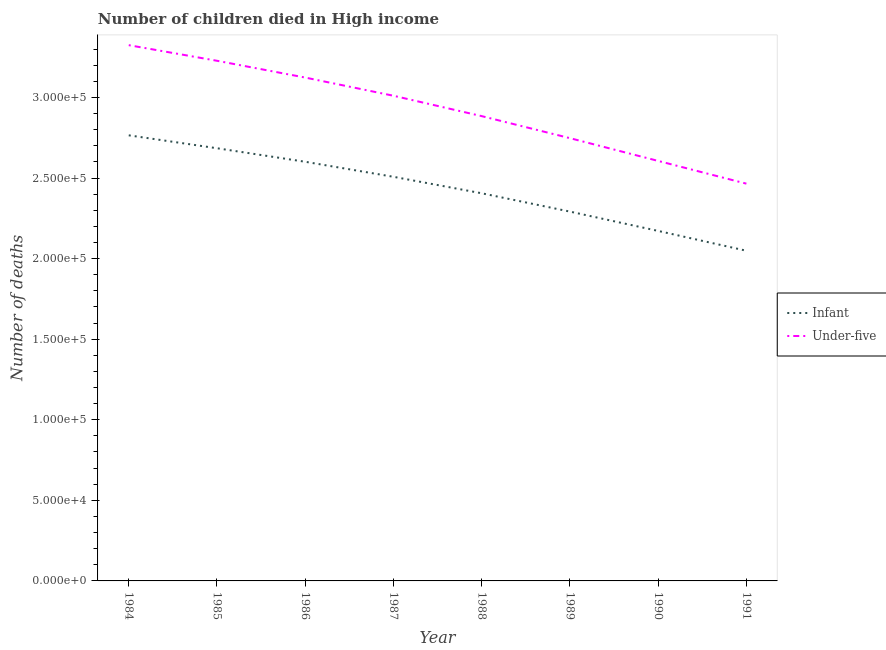How many different coloured lines are there?
Your answer should be compact. 2. Is the number of lines equal to the number of legend labels?
Provide a succinct answer. Yes. What is the number of infant deaths in 1989?
Provide a succinct answer. 2.29e+05. Across all years, what is the maximum number of under-five deaths?
Your response must be concise. 3.32e+05. Across all years, what is the minimum number of under-five deaths?
Provide a short and direct response. 2.46e+05. In which year was the number of infant deaths maximum?
Provide a succinct answer. 1984. In which year was the number of under-five deaths minimum?
Keep it short and to the point. 1991. What is the total number of under-five deaths in the graph?
Make the answer very short. 2.34e+06. What is the difference between the number of under-five deaths in 1987 and that in 1991?
Keep it short and to the point. 5.46e+04. What is the difference between the number of under-five deaths in 1986 and the number of infant deaths in 1984?
Provide a short and direct response. 3.58e+04. What is the average number of under-five deaths per year?
Offer a terse response. 2.92e+05. In the year 1988, what is the difference between the number of under-five deaths and number of infant deaths?
Your answer should be compact. 4.79e+04. What is the ratio of the number of under-five deaths in 1988 to that in 1991?
Your response must be concise. 1.17. Is the difference between the number of infant deaths in 1990 and 1991 greater than the difference between the number of under-five deaths in 1990 and 1991?
Provide a succinct answer. No. What is the difference between the highest and the second highest number of under-five deaths?
Provide a short and direct response. 9692. What is the difference between the highest and the lowest number of infant deaths?
Provide a succinct answer. 7.16e+04. In how many years, is the number of infant deaths greater than the average number of infant deaths taken over all years?
Keep it short and to the point. 4. How many lines are there?
Your answer should be compact. 2. Does the graph contain any zero values?
Give a very brief answer. No. How many legend labels are there?
Your answer should be very brief. 2. How are the legend labels stacked?
Your answer should be compact. Vertical. What is the title of the graph?
Your answer should be very brief. Number of children died in High income. What is the label or title of the X-axis?
Offer a very short reply. Year. What is the label or title of the Y-axis?
Keep it short and to the point. Number of deaths. What is the Number of deaths of Infant in 1984?
Keep it short and to the point. 2.76e+05. What is the Number of deaths of Under-five in 1984?
Make the answer very short. 3.32e+05. What is the Number of deaths in Infant in 1985?
Ensure brevity in your answer.  2.68e+05. What is the Number of deaths in Under-five in 1985?
Ensure brevity in your answer.  3.23e+05. What is the Number of deaths in Infant in 1986?
Provide a succinct answer. 2.60e+05. What is the Number of deaths of Under-five in 1986?
Offer a terse response. 3.12e+05. What is the Number of deaths in Infant in 1987?
Provide a succinct answer. 2.51e+05. What is the Number of deaths of Under-five in 1987?
Give a very brief answer. 3.01e+05. What is the Number of deaths of Infant in 1988?
Give a very brief answer. 2.41e+05. What is the Number of deaths of Under-five in 1988?
Provide a short and direct response. 2.88e+05. What is the Number of deaths of Infant in 1989?
Provide a succinct answer. 2.29e+05. What is the Number of deaths in Under-five in 1989?
Make the answer very short. 2.75e+05. What is the Number of deaths in Infant in 1990?
Offer a terse response. 2.17e+05. What is the Number of deaths of Under-five in 1990?
Ensure brevity in your answer.  2.61e+05. What is the Number of deaths of Infant in 1991?
Provide a short and direct response. 2.05e+05. What is the Number of deaths of Under-five in 1991?
Offer a terse response. 2.46e+05. Across all years, what is the maximum Number of deaths of Infant?
Your response must be concise. 2.76e+05. Across all years, what is the maximum Number of deaths in Under-five?
Offer a very short reply. 3.32e+05. Across all years, what is the minimum Number of deaths in Infant?
Your answer should be compact. 2.05e+05. Across all years, what is the minimum Number of deaths of Under-five?
Make the answer very short. 2.46e+05. What is the total Number of deaths of Infant in the graph?
Offer a very short reply. 1.95e+06. What is the total Number of deaths in Under-five in the graph?
Your answer should be very brief. 2.34e+06. What is the difference between the Number of deaths of Infant in 1984 and that in 1985?
Keep it short and to the point. 8018. What is the difference between the Number of deaths of Under-five in 1984 and that in 1985?
Keep it short and to the point. 9692. What is the difference between the Number of deaths in Infant in 1984 and that in 1986?
Ensure brevity in your answer.  1.64e+04. What is the difference between the Number of deaths in Under-five in 1984 and that in 1986?
Offer a very short reply. 2.01e+04. What is the difference between the Number of deaths in Infant in 1984 and that in 1987?
Give a very brief answer. 2.57e+04. What is the difference between the Number of deaths of Under-five in 1984 and that in 1987?
Ensure brevity in your answer.  3.14e+04. What is the difference between the Number of deaths in Infant in 1984 and that in 1988?
Give a very brief answer. 3.60e+04. What is the difference between the Number of deaths of Under-five in 1984 and that in 1988?
Your answer should be compact. 4.40e+04. What is the difference between the Number of deaths in Infant in 1984 and that in 1989?
Offer a very short reply. 4.73e+04. What is the difference between the Number of deaths of Under-five in 1984 and that in 1989?
Keep it short and to the point. 5.77e+04. What is the difference between the Number of deaths in Infant in 1984 and that in 1990?
Provide a succinct answer. 5.93e+04. What is the difference between the Number of deaths in Under-five in 1984 and that in 1990?
Ensure brevity in your answer.  7.18e+04. What is the difference between the Number of deaths of Infant in 1984 and that in 1991?
Give a very brief answer. 7.16e+04. What is the difference between the Number of deaths of Under-five in 1984 and that in 1991?
Your answer should be very brief. 8.59e+04. What is the difference between the Number of deaths of Infant in 1985 and that in 1986?
Your answer should be compact. 8395. What is the difference between the Number of deaths of Under-five in 1985 and that in 1986?
Ensure brevity in your answer.  1.04e+04. What is the difference between the Number of deaths in Infant in 1985 and that in 1987?
Your answer should be compact. 1.77e+04. What is the difference between the Number of deaths in Under-five in 1985 and that in 1987?
Make the answer very short. 2.17e+04. What is the difference between the Number of deaths of Infant in 1985 and that in 1988?
Your answer should be very brief. 2.79e+04. What is the difference between the Number of deaths in Under-five in 1985 and that in 1988?
Give a very brief answer. 3.43e+04. What is the difference between the Number of deaths of Infant in 1985 and that in 1989?
Offer a terse response. 3.93e+04. What is the difference between the Number of deaths of Under-five in 1985 and that in 1989?
Make the answer very short. 4.80e+04. What is the difference between the Number of deaths in Infant in 1985 and that in 1990?
Offer a very short reply. 5.13e+04. What is the difference between the Number of deaths in Under-five in 1985 and that in 1990?
Offer a terse response. 6.21e+04. What is the difference between the Number of deaths of Infant in 1985 and that in 1991?
Your answer should be very brief. 6.36e+04. What is the difference between the Number of deaths in Under-five in 1985 and that in 1991?
Make the answer very short. 7.62e+04. What is the difference between the Number of deaths of Infant in 1986 and that in 1987?
Provide a succinct answer. 9321. What is the difference between the Number of deaths in Under-five in 1986 and that in 1987?
Offer a very short reply. 1.13e+04. What is the difference between the Number of deaths of Infant in 1986 and that in 1988?
Provide a succinct answer. 1.95e+04. What is the difference between the Number of deaths in Under-five in 1986 and that in 1988?
Provide a short and direct response. 2.39e+04. What is the difference between the Number of deaths of Infant in 1986 and that in 1989?
Keep it short and to the point. 3.09e+04. What is the difference between the Number of deaths of Under-five in 1986 and that in 1989?
Give a very brief answer. 3.76e+04. What is the difference between the Number of deaths of Infant in 1986 and that in 1990?
Your response must be concise. 4.29e+04. What is the difference between the Number of deaths of Under-five in 1986 and that in 1990?
Your answer should be very brief. 5.17e+04. What is the difference between the Number of deaths of Infant in 1986 and that in 1991?
Ensure brevity in your answer.  5.52e+04. What is the difference between the Number of deaths in Under-five in 1986 and that in 1991?
Provide a succinct answer. 6.58e+04. What is the difference between the Number of deaths of Infant in 1987 and that in 1988?
Your answer should be compact. 1.02e+04. What is the difference between the Number of deaths of Under-five in 1987 and that in 1988?
Keep it short and to the point. 1.26e+04. What is the difference between the Number of deaths of Infant in 1987 and that in 1989?
Provide a short and direct response. 2.16e+04. What is the difference between the Number of deaths in Under-five in 1987 and that in 1989?
Ensure brevity in your answer.  2.63e+04. What is the difference between the Number of deaths of Infant in 1987 and that in 1990?
Offer a terse response. 3.36e+04. What is the difference between the Number of deaths of Under-five in 1987 and that in 1990?
Ensure brevity in your answer.  4.04e+04. What is the difference between the Number of deaths in Infant in 1987 and that in 1991?
Offer a terse response. 4.59e+04. What is the difference between the Number of deaths of Under-five in 1987 and that in 1991?
Your answer should be compact. 5.46e+04. What is the difference between the Number of deaths of Infant in 1988 and that in 1989?
Offer a terse response. 1.14e+04. What is the difference between the Number of deaths of Under-five in 1988 and that in 1989?
Give a very brief answer. 1.37e+04. What is the difference between the Number of deaths in Infant in 1988 and that in 1990?
Ensure brevity in your answer.  2.34e+04. What is the difference between the Number of deaths in Under-five in 1988 and that in 1990?
Offer a terse response. 2.78e+04. What is the difference between the Number of deaths in Infant in 1988 and that in 1991?
Offer a very short reply. 3.57e+04. What is the difference between the Number of deaths of Under-five in 1988 and that in 1991?
Your answer should be very brief. 4.19e+04. What is the difference between the Number of deaths of Infant in 1989 and that in 1990?
Your response must be concise. 1.20e+04. What is the difference between the Number of deaths in Under-five in 1989 and that in 1990?
Your answer should be compact. 1.41e+04. What is the difference between the Number of deaths of Infant in 1989 and that in 1991?
Give a very brief answer. 2.43e+04. What is the difference between the Number of deaths in Under-five in 1989 and that in 1991?
Provide a succinct answer. 2.82e+04. What is the difference between the Number of deaths in Infant in 1990 and that in 1991?
Provide a short and direct response. 1.23e+04. What is the difference between the Number of deaths of Under-five in 1990 and that in 1991?
Offer a very short reply. 1.41e+04. What is the difference between the Number of deaths of Infant in 1984 and the Number of deaths of Under-five in 1985?
Give a very brief answer. -4.63e+04. What is the difference between the Number of deaths in Infant in 1984 and the Number of deaths in Under-five in 1986?
Your answer should be very brief. -3.58e+04. What is the difference between the Number of deaths of Infant in 1984 and the Number of deaths of Under-five in 1987?
Provide a short and direct response. -2.46e+04. What is the difference between the Number of deaths of Infant in 1984 and the Number of deaths of Under-five in 1988?
Your response must be concise. -1.19e+04. What is the difference between the Number of deaths of Infant in 1984 and the Number of deaths of Under-five in 1989?
Your response must be concise. 1762. What is the difference between the Number of deaths of Infant in 1984 and the Number of deaths of Under-five in 1990?
Your response must be concise. 1.59e+04. What is the difference between the Number of deaths in Infant in 1984 and the Number of deaths in Under-five in 1991?
Your answer should be compact. 3.00e+04. What is the difference between the Number of deaths in Infant in 1985 and the Number of deaths in Under-five in 1986?
Provide a succinct answer. -4.39e+04. What is the difference between the Number of deaths in Infant in 1985 and the Number of deaths in Under-five in 1987?
Your answer should be compact. -3.26e+04. What is the difference between the Number of deaths in Infant in 1985 and the Number of deaths in Under-five in 1988?
Offer a terse response. -1.99e+04. What is the difference between the Number of deaths of Infant in 1985 and the Number of deaths of Under-five in 1989?
Keep it short and to the point. -6256. What is the difference between the Number of deaths of Infant in 1985 and the Number of deaths of Under-five in 1990?
Your answer should be very brief. 7872. What is the difference between the Number of deaths in Infant in 1985 and the Number of deaths in Under-five in 1991?
Offer a terse response. 2.20e+04. What is the difference between the Number of deaths in Infant in 1986 and the Number of deaths in Under-five in 1987?
Offer a very short reply. -4.10e+04. What is the difference between the Number of deaths of Infant in 1986 and the Number of deaths of Under-five in 1988?
Your response must be concise. -2.83e+04. What is the difference between the Number of deaths in Infant in 1986 and the Number of deaths in Under-five in 1989?
Provide a succinct answer. -1.47e+04. What is the difference between the Number of deaths in Infant in 1986 and the Number of deaths in Under-five in 1990?
Ensure brevity in your answer.  -523. What is the difference between the Number of deaths of Infant in 1986 and the Number of deaths of Under-five in 1991?
Give a very brief answer. 1.36e+04. What is the difference between the Number of deaths of Infant in 1987 and the Number of deaths of Under-five in 1988?
Ensure brevity in your answer.  -3.76e+04. What is the difference between the Number of deaths of Infant in 1987 and the Number of deaths of Under-five in 1989?
Offer a very short reply. -2.40e+04. What is the difference between the Number of deaths of Infant in 1987 and the Number of deaths of Under-five in 1990?
Your response must be concise. -9844. What is the difference between the Number of deaths in Infant in 1987 and the Number of deaths in Under-five in 1991?
Offer a terse response. 4261. What is the difference between the Number of deaths of Infant in 1988 and the Number of deaths of Under-five in 1989?
Make the answer very short. -3.42e+04. What is the difference between the Number of deaths of Infant in 1988 and the Number of deaths of Under-five in 1990?
Ensure brevity in your answer.  -2.01e+04. What is the difference between the Number of deaths of Infant in 1988 and the Number of deaths of Under-five in 1991?
Offer a terse response. -5960. What is the difference between the Number of deaths of Infant in 1989 and the Number of deaths of Under-five in 1990?
Your answer should be very brief. -3.14e+04. What is the difference between the Number of deaths of Infant in 1989 and the Number of deaths of Under-five in 1991?
Provide a succinct answer. -1.73e+04. What is the difference between the Number of deaths in Infant in 1990 and the Number of deaths in Under-five in 1991?
Keep it short and to the point. -2.93e+04. What is the average Number of deaths in Infant per year?
Offer a very short reply. 2.43e+05. What is the average Number of deaths in Under-five per year?
Provide a short and direct response. 2.92e+05. In the year 1984, what is the difference between the Number of deaths of Infant and Number of deaths of Under-five?
Keep it short and to the point. -5.59e+04. In the year 1985, what is the difference between the Number of deaths of Infant and Number of deaths of Under-five?
Make the answer very short. -5.43e+04. In the year 1986, what is the difference between the Number of deaths in Infant and Number of deaths in Under-five?
Your response must be concise. -5.23e+04. In the year 1987, what is the difference between the Number of deaths in Infant and Number of deaths in Under-five?
Offer a terse response. -5.03e+04. In the year 1988, what is the difference between the Number of deaths in Infant and Number of deaths in Under-five?
Ensure brevity in your answer.  -4.79e+04. In the year 1989, what is the difference between the Number of deaths in Infant and Number of deaths in Under-five?
Give a very brief answer. -4.56e+04. In the year 1990, what is the difference between the Number of deaths in Infant and Number of deaths in Under-five?
Give a very brief answer. -4.34e+04. In the year 1991, what is the difference between the Number of deaths in Infant and Number of deaths in Under-five?
Your answer should be very brief. -4.16e+04. What is the ratio of the Number of deaths of Infant in 1984 to that in 1985?
Provide a succinct answer. 1.03. What is the ratio of the Number of deaths in Infant in 1984 to that in 1986?
Offer a very short reply. 1.06. What is the ratio of the Number of deaths in Under-five in 1984 to that in 1986?
Ensure brevity in your answer.  1.06. What is the ratio of the Number of deaths of Infant in 1984 to that in 1987?
Provide a short and direct response. 1.1. What is the ratio of the Number of deaths of Under-five in 1984 to that in 1987?
Ensure brevity in your answer.  1.1. What is the ratio of the Number of deaths of Infant in 1984 to that in 1988?
Make the answer very short. 1.15. What is the ratio of the Number of deaths of Under-five in 1984 to that in 1988?
Make the answer very short. 1.15. What is the ratio of the Number of deaths of Infant in 1984 to that in 1989?
Your response must be concise. 1.21. What is the ratio of the Number of deaths in Under-five in 1984 to that in 1989?
Offer a very short reply. 1.21. What is the ratio of the Number of deaths in Infant in 1984 to that in 1990?
Your answer should be compact. 1.27. What is the ratio of the Number of deaths of Under-five in 1984 to that in 1990?
Your answer should be compact. 1.28. What is the ratio of the Number of deaths of Infant in 1984 to that in 1991?
Offer a very short reply. 1.35. What is the ratio of the Number of deaths in Under-five in 1984 to that in 1991?
Your response must be concise. 1.35. What is the ratio of the Number of deaths in Infant in 1985 to that in 1986?
Give a very brief answer. 1.03. What is the ratio of the Number of deaths of Infant in 1985 to that in 1987?
Offer a terse response. 1.07. What is the ratio of the Number of deaths of Under-five in 1985 to that in 1987?
Your response must be concise. 1.07. What is the ratio of the Number of deaths in Infant in 1985 to that in 1988?
Ensure brevity in your answer.  1.12. What is the ratio of the Number of deaths in Under-five in 1985 to that in 1988?
Your answer should be very brief. 1.12. What is the ratio of the Number of deaths of Infant in 1985 to that in 1989?
Make the answer very short. 1.17. What is the ratio of the Number of deaths of Under-five in 1985 to that in 1989?
Ensure brevity in your answer.  1.17. What is the ratio of the Number of deaths of Infant in 1985 to that in 1990?
Keep it short and to the point. 1.24. What is the ratio of the Number of deaths in Under-five in 1985 to that in 1990?
Provide a succinct answer. 1.24. What is the ratio of the Number of deaths in Infant in 1985 to that in 1991?
Offer a very short reply. 1.31. What is the ratio of the Number of deaths of Under-five in 1985 to that in 1991?
Give a very brief answer. 1.31. What is the ratio of the Number of deaths of Infant in 1986 to that in 1987?
Keep it short and to the point. 1.04. What is the ratio of the Number of deaths of Under-five in 1986 to that in 1987?
Your response must be concise. 1.04. What is the ratio of the Number of deaths of Infant in 1986 to that in 1988?
Keep it short and to the point. 1.08. What is the ratio of the Number of deaths in Under-five in 1986 to that in 1988?
Provide a short and direct response. 1.08. What is the ratio of the Number of deaths in Infant in 1986 to that in 1989?
Your answer should be compact. 1.13. What is the ratio of the Number of deaths of Under-five in 1986 to that in 1989?
Your response must be concise. 1.14. What is the ratio of the Number of deaths in Infant in 1986 to that in 1990?
Offer a terse response. 1.2. What is the ratio of the Number of deaths in Under-five in 1986 to that in 1990?
Offer a terse response. 1.2. What is the ratio of the Number of deaths in Infant in 1986 to that in 1991?
Provide a short and direct response. 1.27. What is the ratio of the Number of deaths of Under-five in 1986 to that in 1991?
Provide a short and direct response. 1.27. What is the ratio of the Number of deaths of Infant in 1987 to that in 1988?
Ensure brevity in your answer.  1.04. What is the ratio of the Number of deaths of Under-five in 1987 to that in 1988?
Offer a very short reply. 1.04. What is the ratio of the Number of deaths in Infant in 1987 to that in 1989?
Keep it short and to the point. 1.09. What is the ratio of the Number of deaths in Under-five in 1987 to that in 1989?
Provide a short and direct response. 1.1. What is the ratio of the Number of deaths in Infant in 1987 to that in 1990?
Offer a very short reply. 1.15. What is the ratio of the Number of deaths of Under-five in 1987 to that in 1990?
Ensure brevity in your answer.  1.16. What is the ratio of the Number of deaths in Infant in 1987 to that in 1991?
Provide a succinct answer. 1.22. What is the ratio of the Number of deaths in Under-five in 1987 to that in 1991?
Your response must be concise. 1.22. What is the ratio of the Number of deaths in Infant in 1988 to that in 1989?
Provide a short and direct response. 1.05. What is the ratio of the Number of deaths of Under-five in 1988 to that in 1989?
Ensure brevity in your answer.  1.05. What is the ratio of the Number of deaths in Infant in 1988 to that in 1990?
Your answer should be very brief. 1.11. What is the ratio of the Number of deaths in Under-five in 1988 to that in 1990?
Your response must be concise. 1.11. What is the ratio of the Number of deaths of Infant in 1988 to that in 1991?
Keep it short and to the point. 1.17. What is the ratio of the Number of deaths in Under-five in 1988 to that in 1991?
Provide a short and direct response. 1.17. What is the ratio of the Number of deaths of Infant in 1989 to that in 1990?
Keep it short and to the point. 1.06. What is the ratio of the Number of deaths of Under-five in 1989 to that in 1990?
Your answer should be very brief. 1.05. What is the ratio of the Number of deaths in Infant in 1989 to that in 1991?
Offer a very short reply. 1.12. What is the ratio of the Number of deaths of Under-five in 1989 to that in 1991?
Offer a very short reply. 1.11. What is the ratio of the Number of deaths in Infant in 1990 to that in 1991?
Ensure brevity in your answer.  1.06. What is the ratio of the Number of deaths in Under-five in 1990 to that in 1991?
Offer a terse response. 1.06. What is the difference between the highest and the second highest Number of deaths in Infant?
Give a very brief answer. 8018. What is the difference between the highest and the second highest Number of deaths in Under-five?
Offer a terse response. 9692. What is the difference between the highest and the lowest Number of deaths in Infant?
Your answer should be very brief. 7.16e+04. What is the difference between the highest and the lowest Number of deaths of Under-five?
Ensure brevity in your answer.  8.59e+04. 